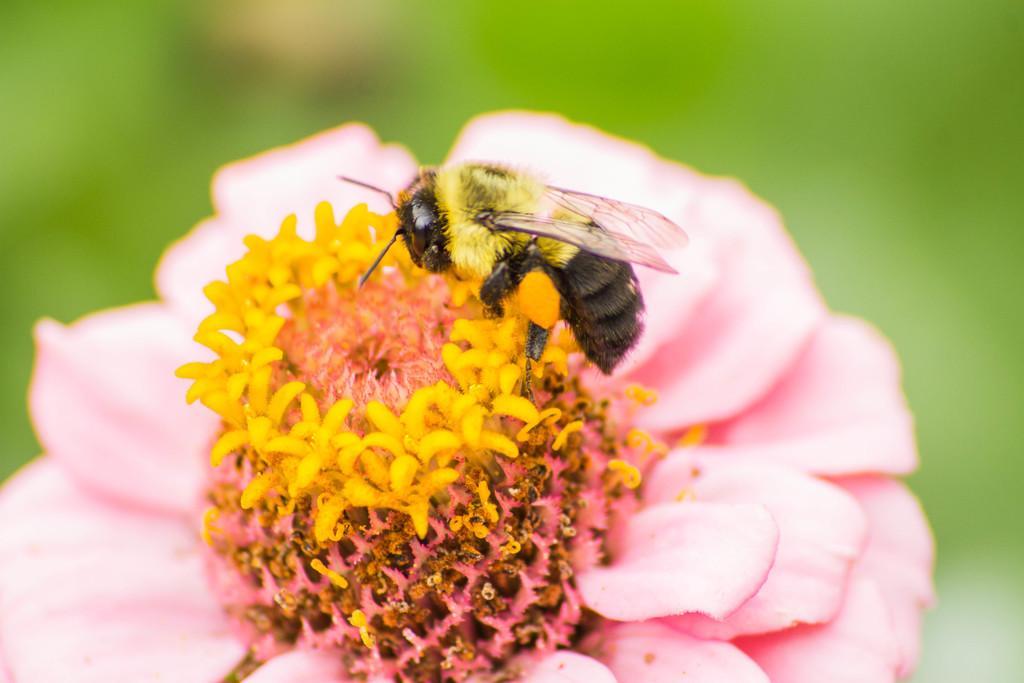Can you describe this image briefly? In this picture we can observe a honey bee which is in yellow and black color on the flower bud. The flower bud is in yellow color. We can observe pink color flower. The background is in green color. 